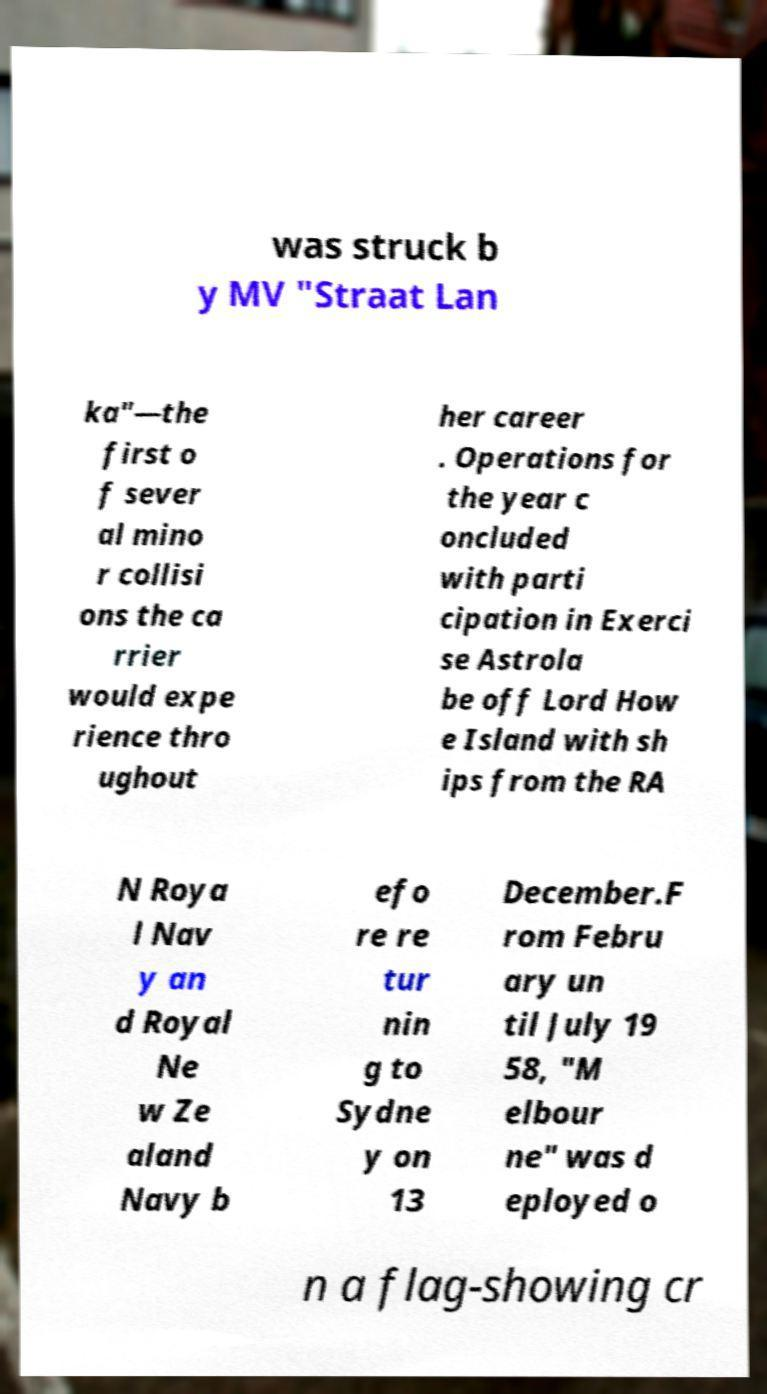Could you extract and type out the text from this image? was struck b y MV "Straat Lan ka"—the first o f sever al mino r collisi ons the ca rrier would expe rience thro ughout her career . Operations for the year c oncluded with parti cipation in Exerci se Astrola be off Lord How e Island with sh ips from the RA N Roya l Nav y an d Royal Ne w Ze aland Navy b efo re re tur nin g to Sydne y on 13 December.F rom Febru ary un til July 19 58, "M elbour ne" was d eployed o n a flag-showing cr 